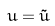<formula> <loc_0><loc_0><loc_500><loc_500>u = \tilde { u }</formula> 